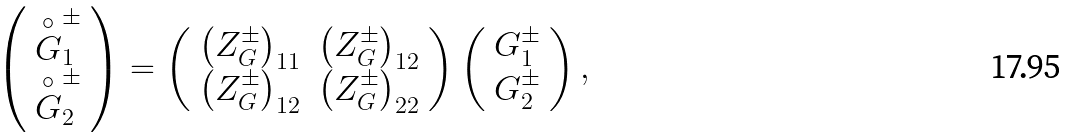<formula> <loc_0><loc_0><loc_500><loc_500>\left ( \begin{array} { c } \stackrel { \circ } { G } _ { 1 } ^ { \pm } \\ \stackrel { \circ } { G } _ { 2 } ^ { \pm } \end{array} \right ) = \left ( \begin{array} { c c } \left ( Z _ { G } ^ { \pm } \right ) _ { 1 1 } & \left ( Z _ { G } ^ { \pm } \right ) _ { 1 2 } \\ \left ( Z _ { G } ^ { \pm } \right ) _ { 1 2 } & \left ( Z _ { G } ^ { \pm } \right ) _ { 2 2 } \end{array} \right ) \left ( \begin{array} { c } { G } _ { 1 } ^ { \pm } \\ { G } _ { 2 } ^ { \pm } \end{array} \right ) ,</formula> 